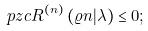<formula> <loc_0><loc_0><loc_500><loc_500>\ p z c R ^ { ( n ) } \left ( \varrho n | \lambda \right ) \leq 0 ;</formula> 